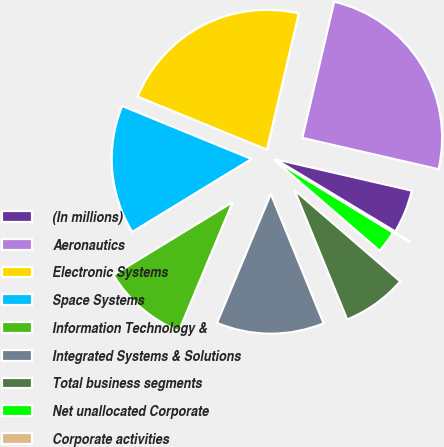Convert chart. <chart><loc_0><loc_0><loc_500><loc_500><pie_chart><fcel>(In millions)<fcel>Aeronautics<fcel>Electronic Systems<fcel>Space Systems<fcel>Information Technology &<fcel>Integrated Systems & Solutions<fcel>Total business segments<fcel>Net unallocated Corporate<fcel>Corporate activities<nl><fcel>5.04%<fcel>24.94%<fcel>22.47%<fcel>14.92%<fcel>9.98%<fcel>12.45%<fcel>7.51%<fcel>2.58%<fcel>0.11%<nl></chart> 